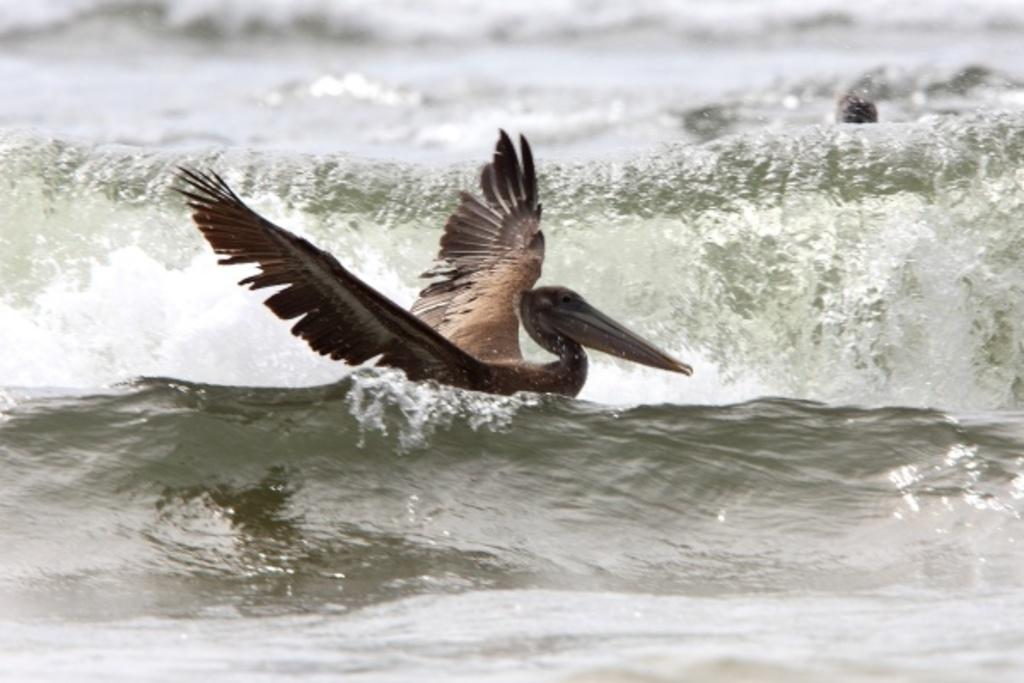What type of bird is in the image? There is a mallard bird in the image. Where is the mallard bird located? The mallard bird is on the water. What type of band can be seen playing in the background of the image? There is no band present in the image; it features a mallard bird on the water. How many bananas are floating next to the mallard bird in the image? There are no bananas present in the image; it features a mallard bird on the water. 